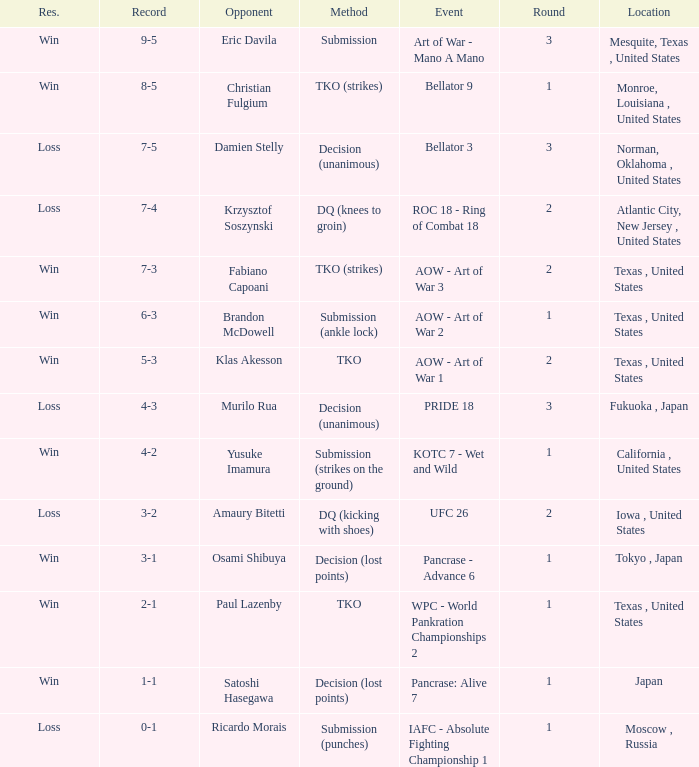Against klas akesson, what is the typical round average? 2.0. 